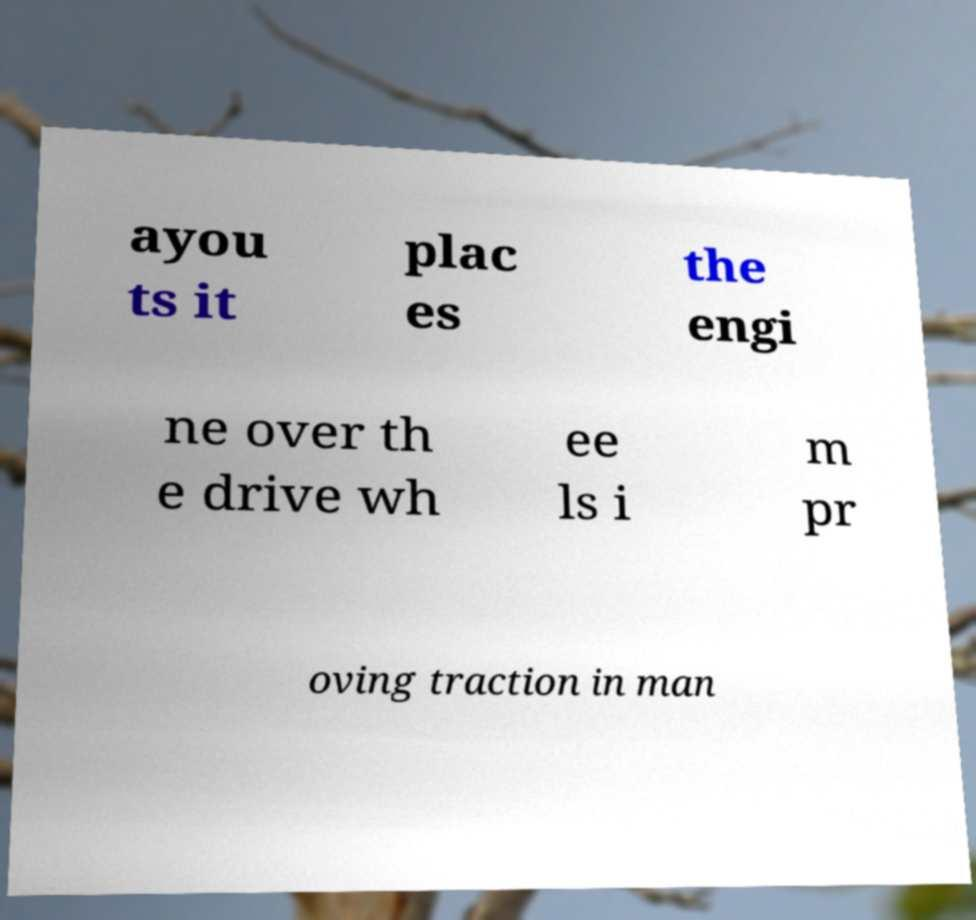For documentation purposes, I need the text within this image transcribed. Could you provide that? ayou ts it plac es the engi ne over th e drive wh ee ls i m pr oving traction in man 